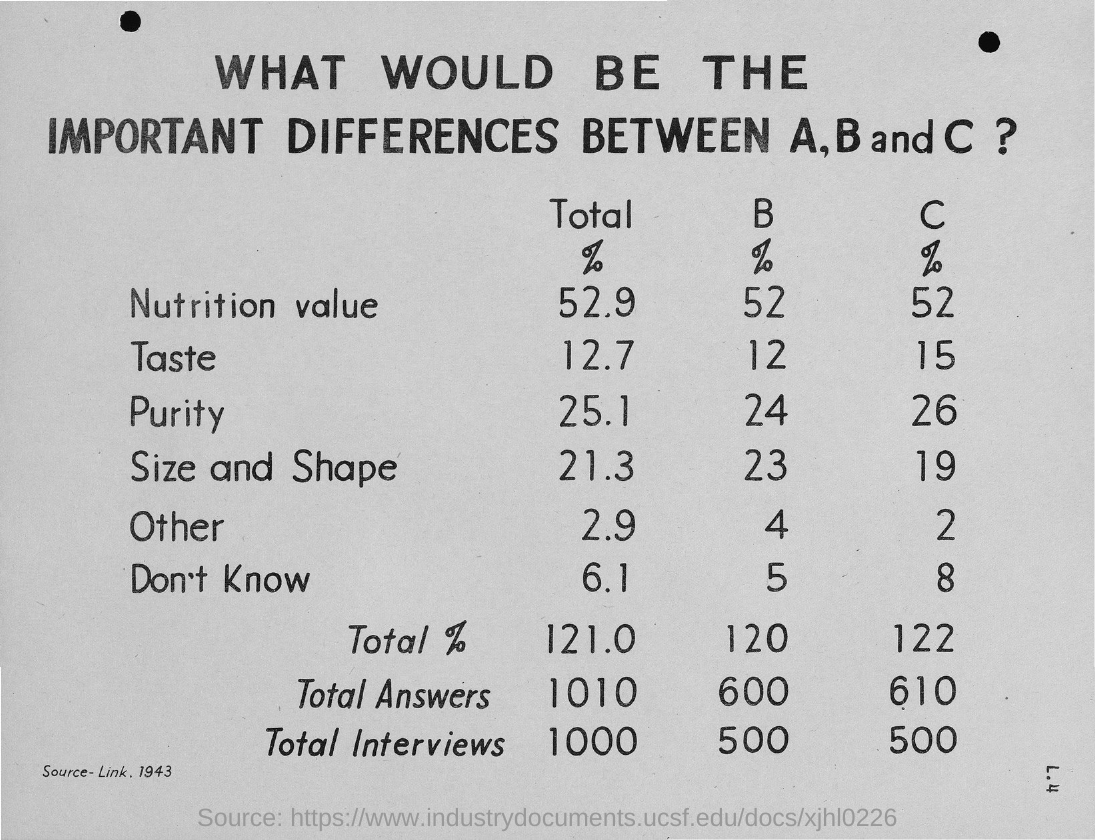What is the percentage value of purity for B?
Offer a very short reply. 24. 